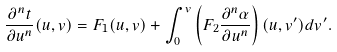<formula> <loc_0><loc_0><loc_500><loc_500>\frac { \partial ^ { n } t } { \partial u ^ { n } } ( u , v ) = F _ { 1 } ( u , v ) + \int _ { 0 } ^ { v } \left ( F _ { 2 } \frac { \partial ^ { n } \alpha } { \partial u ^ { n } } \right ) ( u , v ^ { \prime } ) d v ^ { \prime } .</formula> 